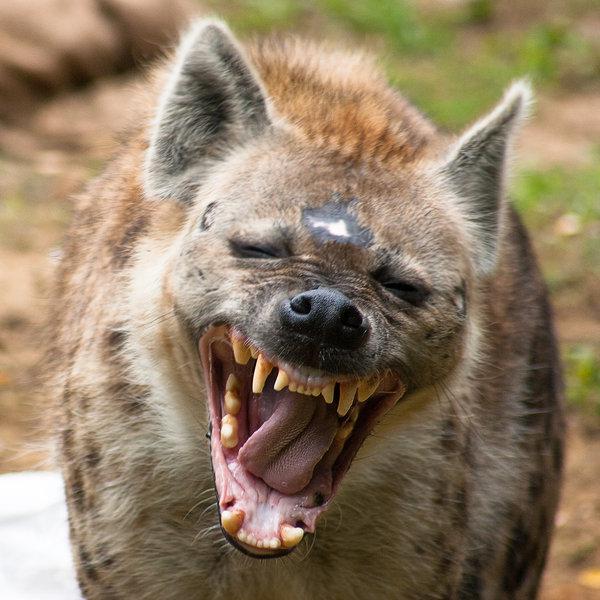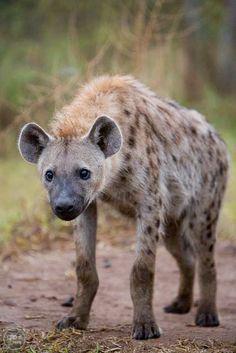The first image is the image on the left, the second image is the image on the right. For the images displayed, is the sentence "The images contain a total of one open-mouthed hyena baring fangs." factually correct? Answer yes or no. Yes. 